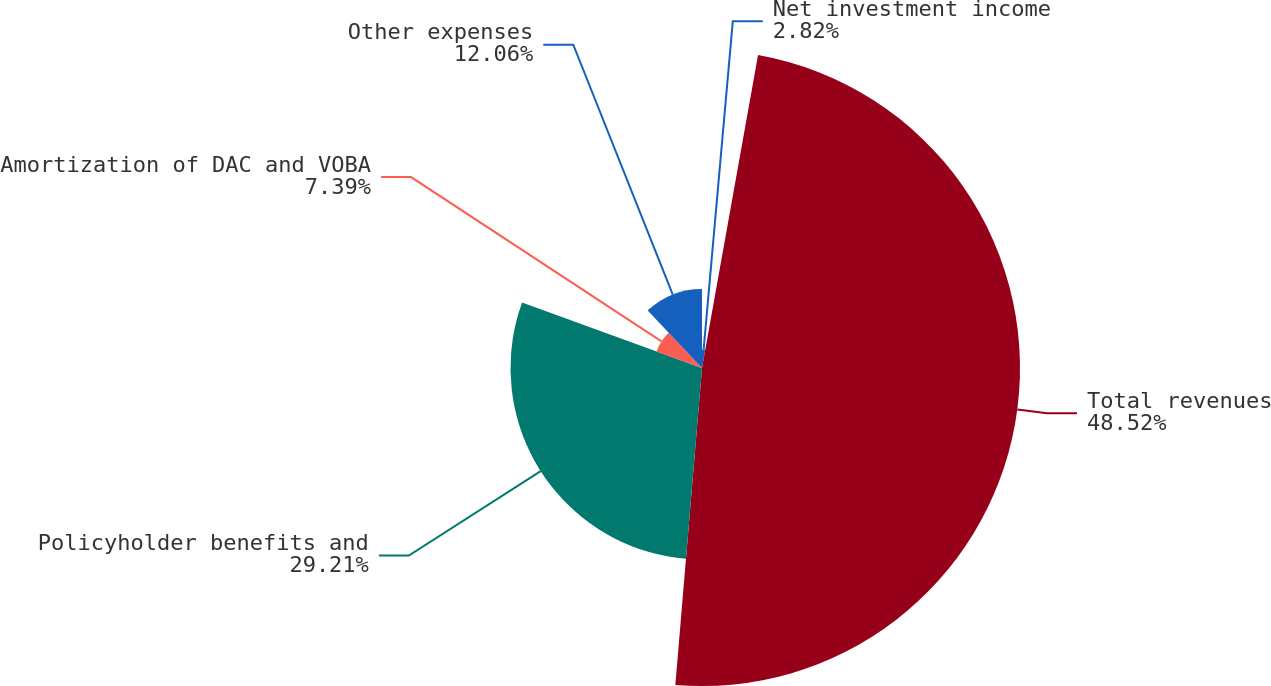<chart> <loc_0><loc_0><loc_500><loc_500><pie_chart><fcel>Net investment income<fcel>Total revenues<fcel>Policyholder benefits and<fcel>Amortization of DAC and VOBA<fcel>Other expenses<nl><fcel>2.82%<fcel>48.51%<fcel>29.21%<fcel>7.39%<fcel>12.06%<nl></chart> 